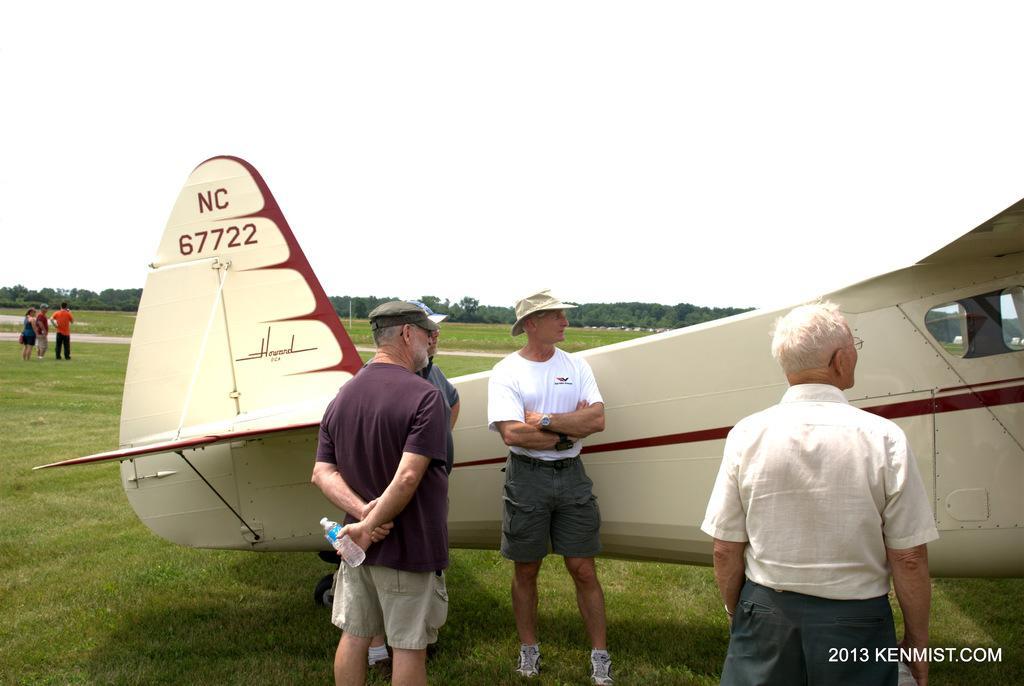Could you give a brief overview of what you see in this image? In the picture we can see a air craft and near it we can see four people are standing and behind the air craft we can see a grass surface and far away from it we can see four people are standing and talking to each other and in the background we can see full of trees and sky. 